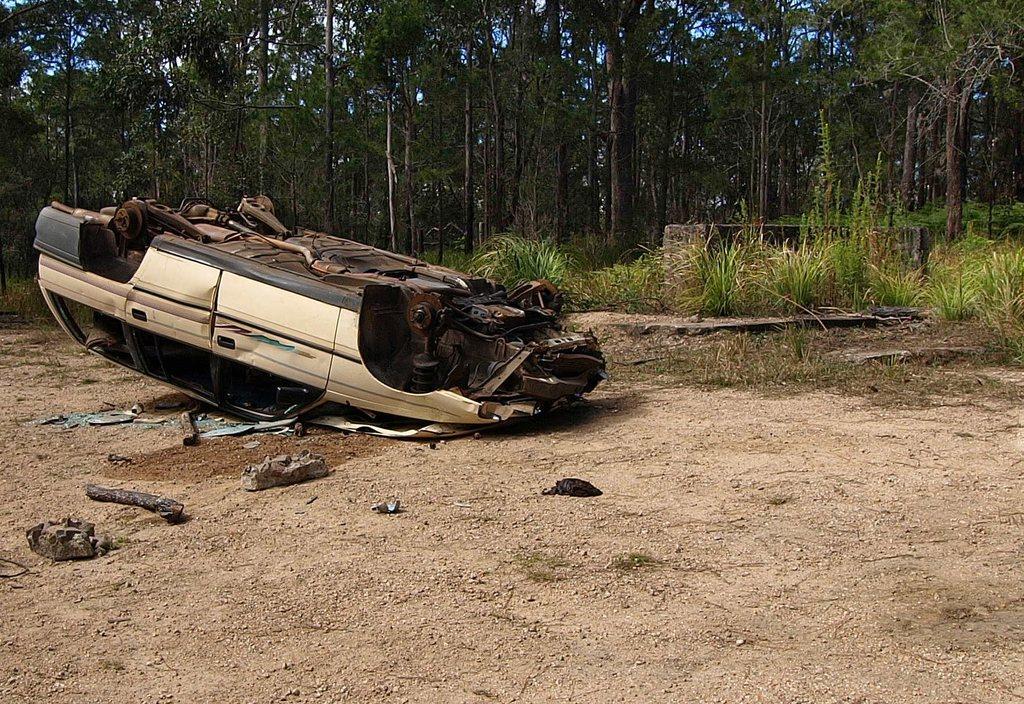Could you give a brief overview of what you see in this image? In this image, we can see a car which is upside down on the ground and there are some small plants on the ground. At the back we can see tall trees which are green in color. 